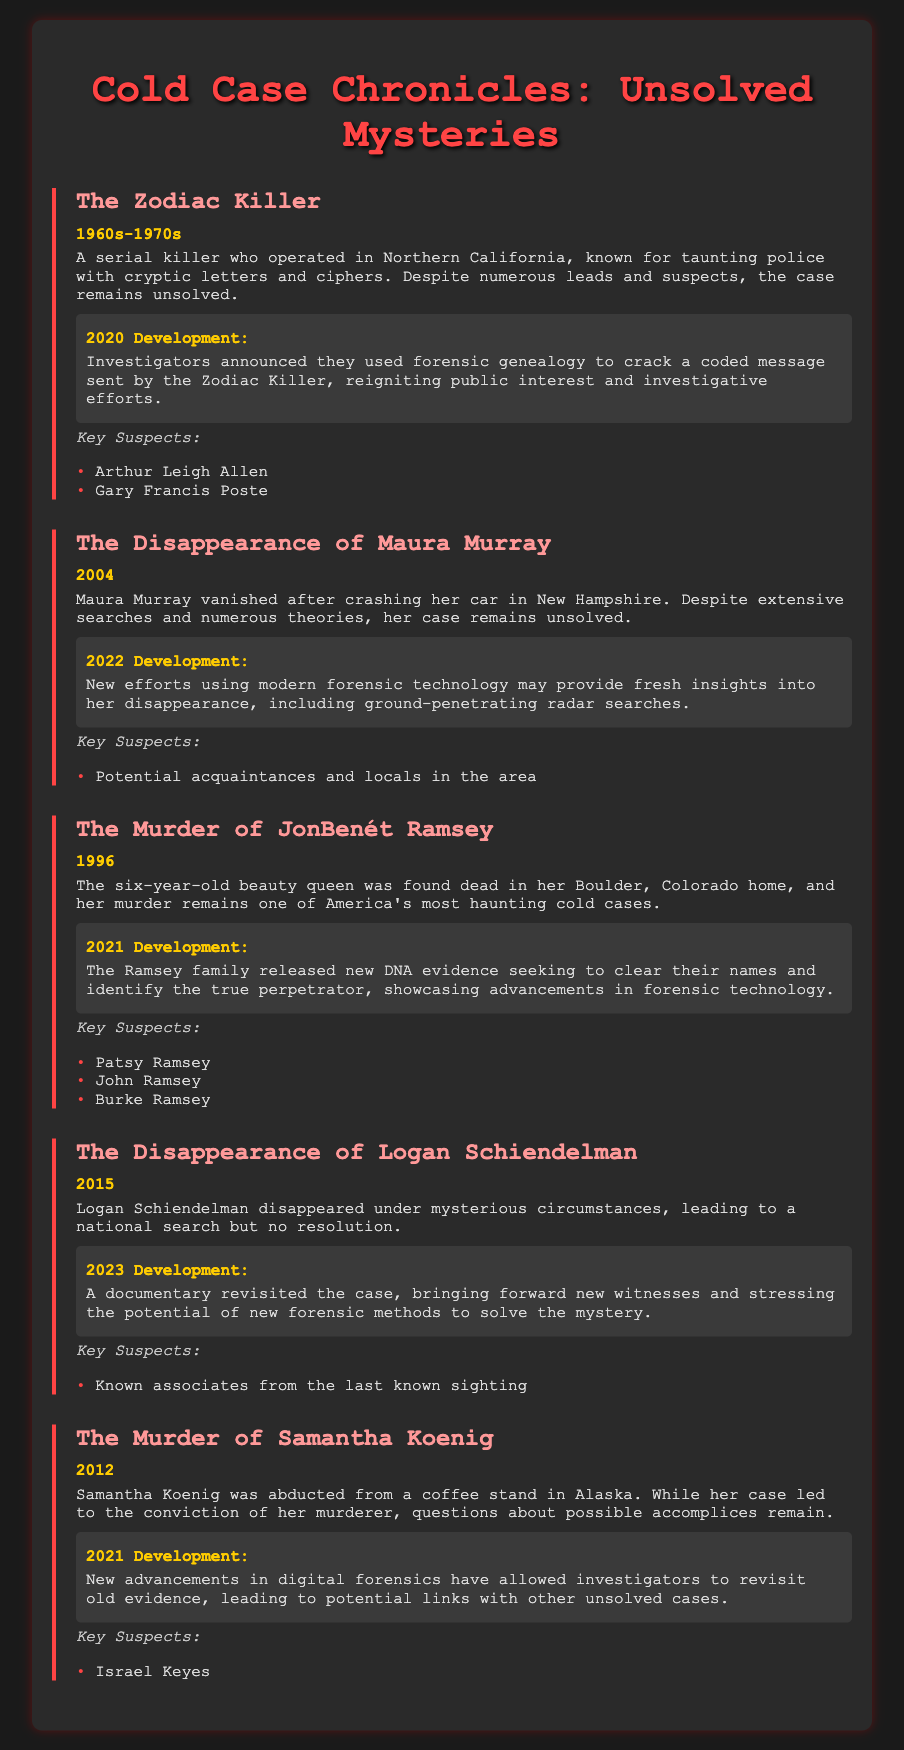What year did the Zodiac Killer operate? The Zodiac Killer operated in the 1960s-1970s.
Answer: 1960s-1970s What forensic technique was used to crack a coded message from the Zodiac Killer? Forensic genealogy was used to crack the coded message.
Answer: Forensic genealogy Who are the key suspects in the JonBenét Ramsey case? The key suspects include Patsy Ramsey, John Ramsey, and Burke Ramsey.
Answer: Patsy Ramsey, John Ramsey, Burke Ramsey What significant development occurred in 2022 regarding Maura Murray's disappearance? New efforts using modern forensic technology may provide fresh insights.
Answer: Fresh insights What type of technology was mentioned in 2023 related to Logan Schiendelman's case? New forensic methods were stressed in relation to the case.
Answer: New forensic methods 